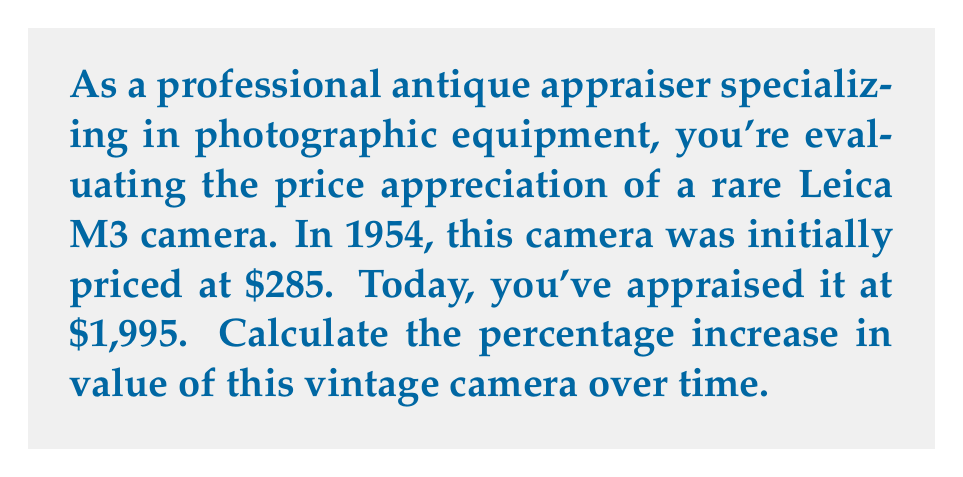Show me your answer to this math problem. To calculate the percentage increase in value, we need to follow these steps:

1. Calculate the difference between the current value and the initial value:
   $\text{Difference} = \text{Current Value} - \text{Initial Value}$
   $\text{Difference} = \$1,995 - \$285 = \$1,710$

2. Divide the difference by the initial value:
   $\text{Ratio} = \frac{\text{Difference}}{\text{Initial Value}} = \frac{\$1,710}{\$285} = 6$

3. Multiply the result by 100 to get the percentage:
   $\text{Percentage Increase} = \text{Ratio} \times 100\%$
   $\text{Percentage Increase} = 6 \times 100\% = 600\%$

We can also express this calculation in a single formula:

$$\text{Percentage Increase} = \frac{\text{Current Value} - \text{Initial Value}}{\text{Initial Value}} \times 100\%$$

$$\text{Percentage Increase} = \frac{\$1,995 - \$285}{\$285} \times 100\% = \frac{\$1,710}{\$285} \times 100\% = 6 \times 100\% = 600\%$$

This means the Leica M3 camera has increased in value by 600% since 1954.
Answer: The percentage increase in value of the vintage Leica M3 camera from 1954 to today is 600%. 